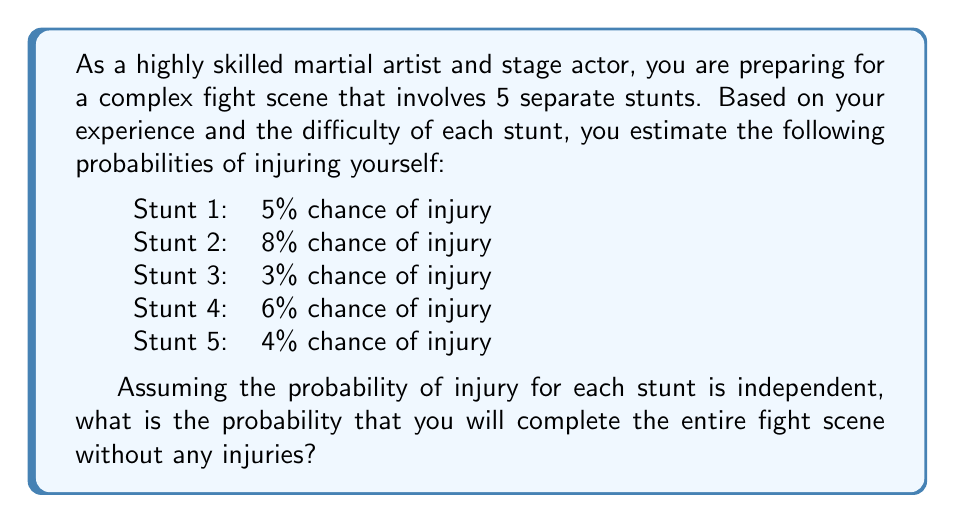Can you answer this question? To solve this problem, we need to follow these steps:

1. Determine the probability of successfully completing each stunt without injury.
2. Multiply these probabilities together to find the probability of completing all stunts without injury.

Let's go through each step:

1. Probability of successfully completing each stunt:
   For each stunt, the probability of success is 1 minus the probability of injury.

   Stunt 1: $P(\text{success}_1) = 1 - 0.05 = 0.95$
   Stunt 2: $P(\text{success}_2) = 1 - 0.08 = 0.92$
   Stunt 3: $P(\text{success}_3) = 1 - 0.03 = 0.97$
   Stunt 4: $P(\text{success}_4) = 1 - 0.06 = 0.94$
   Stunt 5: $P(\text{success}_5) = 1 - 0.04 = 0.96$

2. Probability of completing all stunts without injury:
   Since the events are independent, we multiply the individual probabilities of success:

   $$P(\text{all successful}) = P(\text{success}_1) \times P(\text{success}_2) \times P(\text{success}_3) \times P(\text{success}_4) \times P(\text{success}_5)$$

   $$P(\text{all successful}) = 0.95 \times 0.92 \times 0.97 \times 0.94 \times 0.96$$

   $$P(\text{all successful}) = 0.7642316$$

Therefore, the probability of completing the entire fight scene without any injuries is approximately 0.7642 or 76.42%.
Answer: The probability of completing the entire fight scene without any injuries is approximately 0.7642 or 76.42%. 